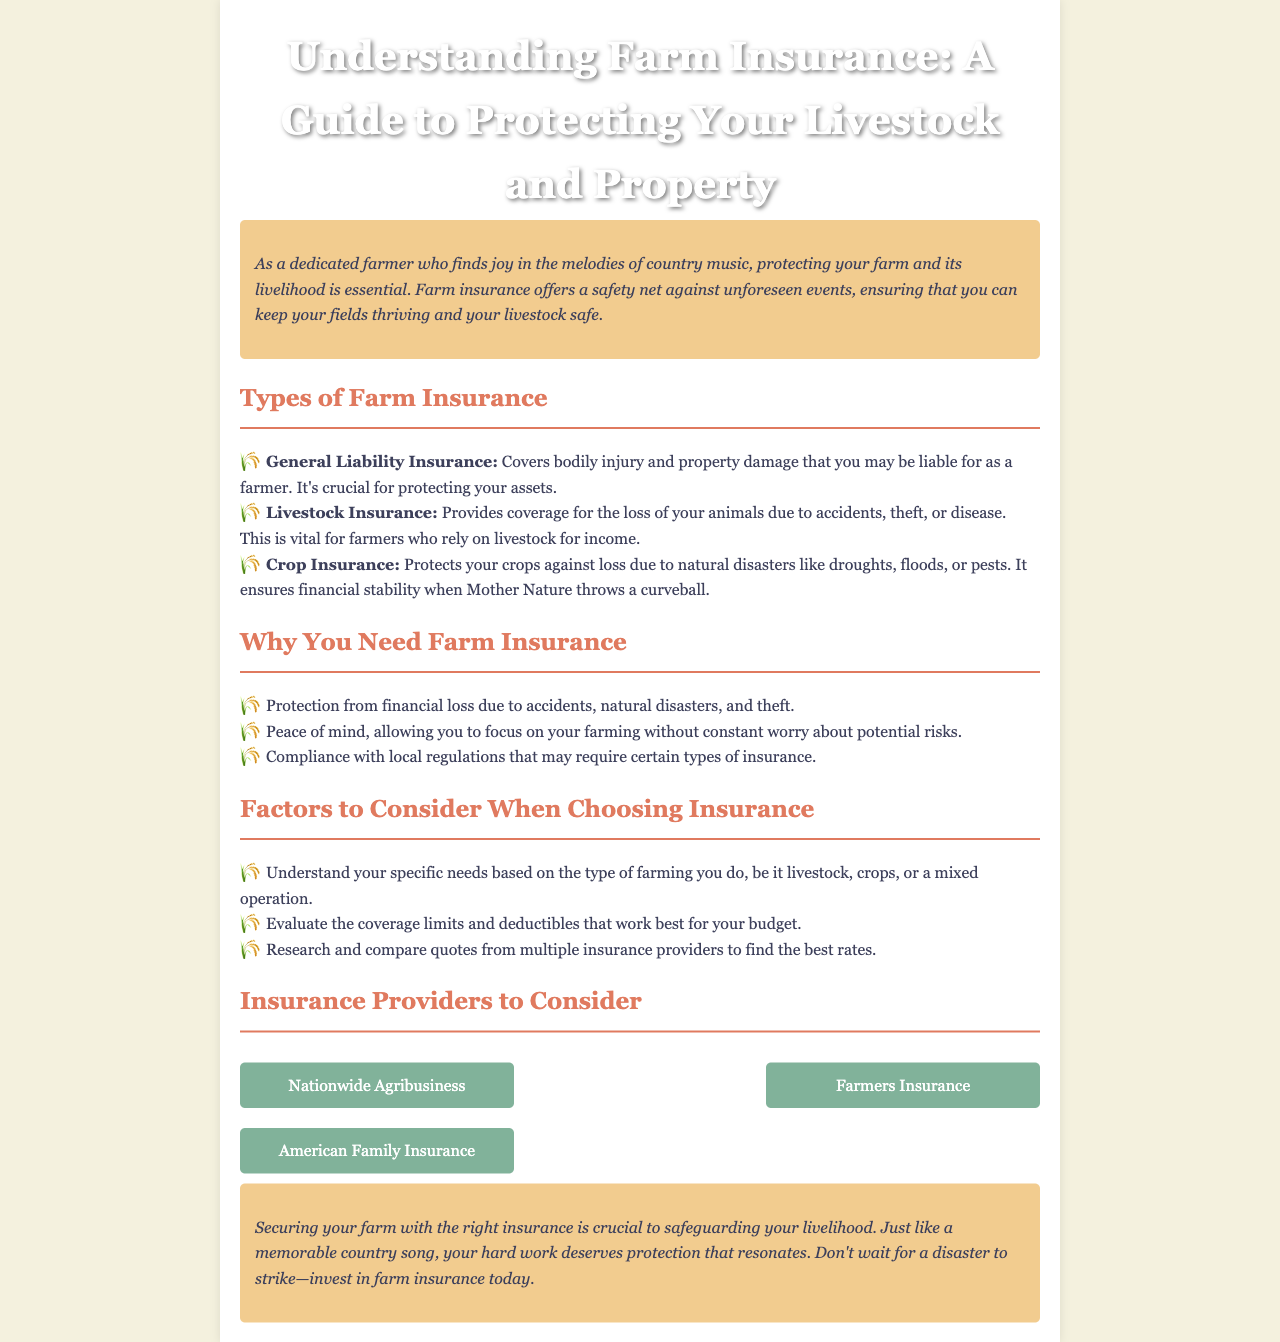What is the title of the newsletter? The title is prominently displayed at the top of the document, clearly indicating the main topic covered within.
Answer: Understanding Farm Insurance: A Guide to Protecting Your Livestock and Property What type of insurance covers loss of animals? The document lists various types of insurance and specifies that this type is related to livestock specifically.
Answer: Livestock Insurance What are the factors to consider when choosing insurance? The document outlines considerations for selecting insurance, covering multiple essential aspects for farmers.
Answer: Specific needs, coverage limits, research and compare quotes How many insurance providers are listed? The document provides a section with three different insurance providers, indicating the options available for the reader.
Answer: 3 What is one reason to get farm insurance? The document states multiple reasons to emphasize the necessity of farm insurance for farmers.
Answer: Protection from financial loss What type of insurance protects crops against natural disasters? The document identifies specific insurance that helps safeguard crops in adverse conditions.
Answer: Crop Insurance What color is used for the section headers? The aesthetic choice in the design of the newsletter includes a specific color for the headers that enhances readability.
Answer: E07A5F How is the introduction styled? The introduction has a distinct appearance that sets it apart from the rest of the text, highlighting its importance.
Answer: Italicized with a background color 